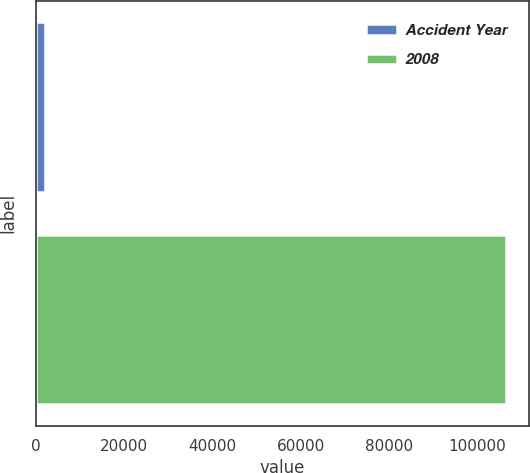Convert chart to OTSL. <chart><loc_0><loc_0><loc_500><loc_500><bar_chart><fcel>Accident Year<fcel>2008<nl><fcel>2016<fcel>106428<nl></chart> 